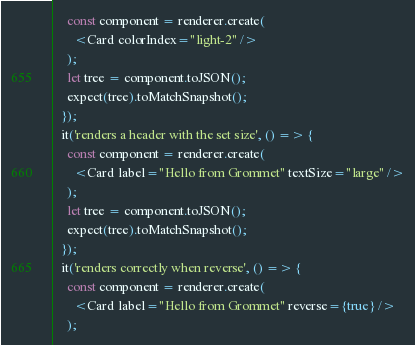Convert code to text. <code><loc_0><loc_0><loc_500><loc_500><_JavaScript_>    const component = renderer.create(
      <Card colorIndex="light-2" />
    );
    let tree = component.toJSON();
    expect(tree).toMatchSnapshot();
  });
  it('renders a header with the set size', () => {
    const component = renderer.create(
      <Card label="Hello from Grommet" textSize="large" />
    );
    let tree = component.toJSON();
    expect(tree).toMatchSnapshot();
  });
  it('renders correctly when reverse', () => {
    const component = renderer.create(
      <Card label="Hello from Grommet" reverse={true} />
    );</code> 